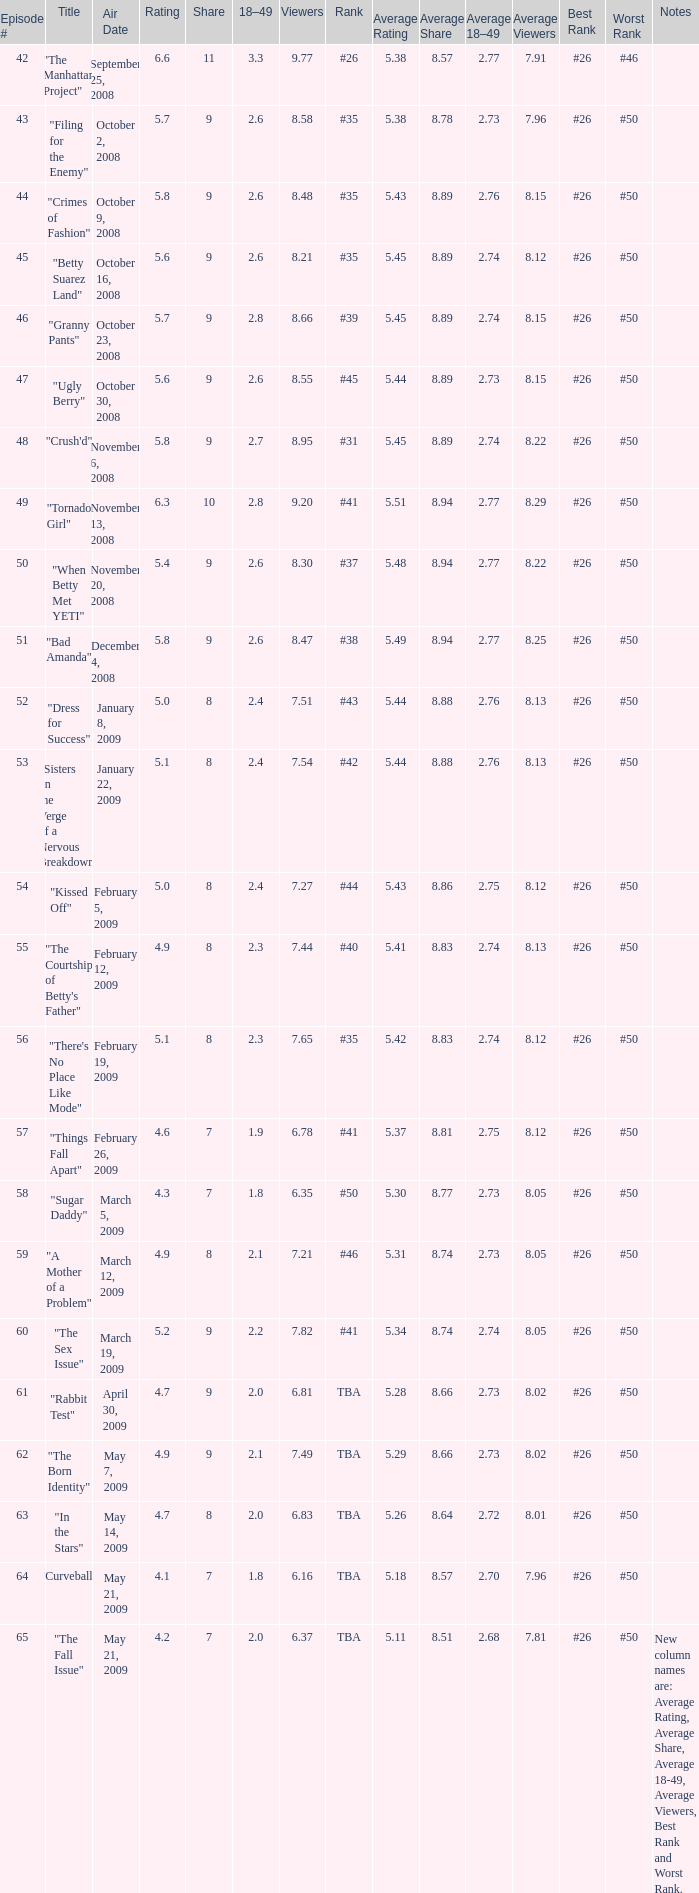What is the average Episode # with a 7 share and 18–49 is less than 2 and the Air Date of may 21, 2009? 64.0. 